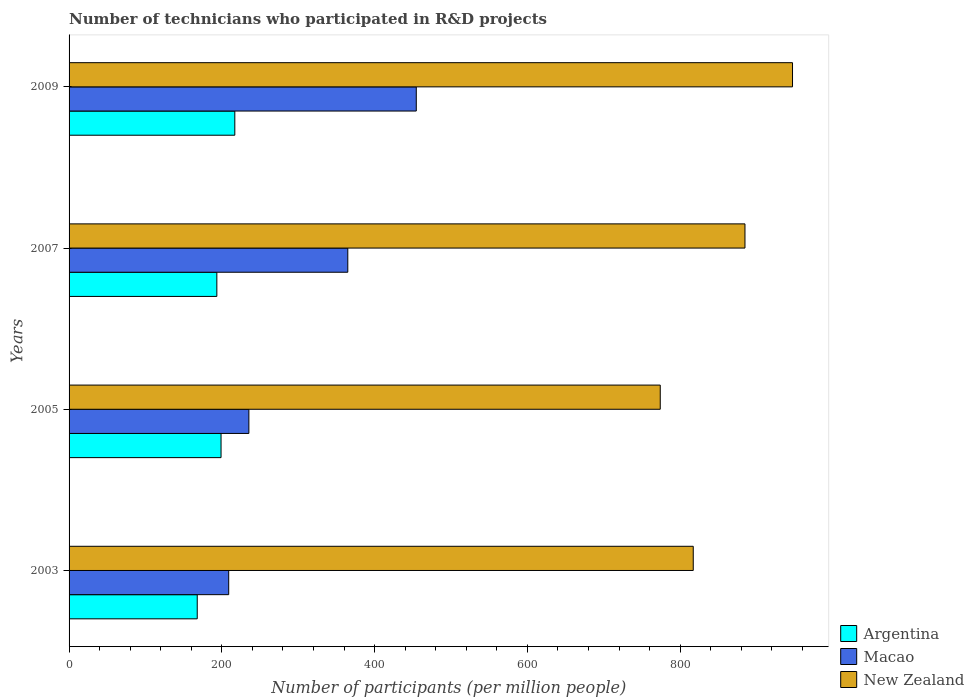How many groups of bars are there?
Offer a very short reply. 4. Are the number of bars on each tick of the Y-axis equal?
Provide a short and direct response. Yes. How many bars are there on the 1st tick from the top?
Provide a short and direct response. 3. What is the label of the 1st group of bars from the top?
Ensure brevity in your answer.  2009. What is the number of technicians who participated in R&D projects in New Zealand in 2005?
Your answer should be very brief. 773.94. Across all years, what is the maximum number of technicians who participated in R&D projects in Argentina?
Provide a short and direct response. 216.97. Across all years, what is the minimum number of technicians who participated in R&D projects in Macao?
Your response must be concise. 208.98. What is the total number of technicians who participated in R&D projects in New Zealand in the graph?
Make the answer very short. 3422.98. What is the difference between the number of technicians who participated in R&D projects in Argentina in 2003 and that in 2007?
Provide a succinct answer. -25.65. What is the difference between the number of technicians who participated in R&D projects in New Zealand in 2009 and the number of technicians who participated in R&D projects in Macao in 2003?
Give a very brief answer. 738.09. What is the average number of technicians who participated in R&D projects in Macao per year?
Your answer should be compact. 315.95. In the year 2005, what is the difference between the number of technicians who participated in R&D projects in New Zealand and number of technicians who participated in R&D projects in Macao?
Keep it short and to the point. 538.54. What is the ratio of the number of technicians who participated in R&D projects in Argentina in 2003 to that in 2005?
Make the answer very short. 0.84. Is the number of technicians who participated in R&D projects in New Zealand in 2003 less than that in 2007?
Offer a terse response. Yes. Is the difference between the number of technicians who participated in R&D projects in New Zealand in 2003 and 2005 greater than the difference between the number of technicians who participated in R&D projects in Macao in 2003 and 2005?
Your response must be concise. Yes. What is the difference between the highest and the second highest number of technicians who participated in R&D projects in Macao?
Your answer should be very brief. 89.65. What is the difference between the highest and the lowest number of technicians who participated in R&D projects in Argentina?
Your answer should be compact. 49.18. In how many years, is the number of technicians who participated in R&D projects in Argentina greater than the average number of technicians who participated in R&D projects in Argentina taken over all years?
Ensure brevity in your answer.  2. Is the sum of the number of technicians who participated in R&D projects in Macao in 2003 and 2005 greater than the maximum number of technicians who participated in R&D projects in Argentina across all years?
Ensure brevity in your answer.  Yes. What does the 2nd bar from the bottom in 2009 represents?
Provide a succinct answer. Macao. How many bars are there?
Provide a short and direct response. 12. How many years are there in the graph?
Ensure brevity in your answer.  4. What is the difference between two consecutive major ticks on the X-axis?
Keep it short and to the point. 200. Where does the legend appear in the graph?
Provide a short and direct response. Bottom right. How are the legend labels stacked?
Your response must be concise. Vertical. What is the title of the graph?
Provide a short and direct response. Number of technicians who participated in R&D projects. Does "Mauritania" appear as one of the legend labels in the graph?
Offer a terse response. No. What is the label or title of the X-axis?
Provide a short and direct response. Number of participants (per million people). What is the label or title of the Y-axis?
Your response must be concise. Years. What is the Number of participants (per million people) in Argentina in 2003?
Your answer should be very brief. 167.79. What is the Number of participants (per million people) in Macao in 2003?
Your answer should be very brief. 208.98. What is the Number of participants (per million people) of New Zealand in 2003?
Provide a succinct answer. 817.12. What is the Number of participants (per million people) of Argentina in 2005?
Give a very brief answer. 198.95. What is the Number of participants (per million people) in Macao in 2005?
Provide a short and direct response. 235.4. What is the Number of participants (per million people) in New Zealand in 2005?
Your response must be concise. 773.94. What is the Number of participants (per million people) in Argentina in 2007?
Give a very brief answer. 193.45. What is the Number of participants (per million people) of Macao in 2007?
Your answer should be very brief. 364.89. What is the Number of participants (per million people) in New Zealand in 2007?
Your answer should be very brief. 884.85. What is the Number of participants (per million people) of Argentina in 2009?
Your response must be concise. 216.97. What is the Number of participants (per million people) in Macao in 2009?
Ensure brevity in your answer.  454.54. What is the Number of participants (per million people) of New Zealand in 2009?
Give a very brief answer. 947.07. Across all years, what is the maximum Number of participants (per million people) of Argentina?
Offer a very short reply. 216.97. Across all years, what is the maximum Number of participants (per million people) of Macao?
Your response must be concise. 454.54. Across all years, what is the maximum Number of participants (per million people) in New Zealand?
Keep it short and to the point. 947.07. Across all years, what is the minimum Number of participants (per million people) of Argentina?
Provide a short and direct response. 167.79. Across all years, what is the minimum Number of participants (per million people) of Macao?
Your answer should be compact. 208.98. Across all years, what is the minimum Number of participants (per million people) in New Zealand?
Your answer should be very brief. 773.94. What is the total Number of participants (per million people) of Argentina in the graph?
Offer a terse response. 777.16. What is the total Number of participants (per million people) in Macao in the graph?
Give a very brief answer. 1263.81. What is the total Number of participants (per million people) of New Zealand in the graph?
Provide a short and direct response. 3422.98. What is the difference between the Number of participants (per million people) of Argentina in 2003 and that in 2005?
Ensure brevity in your answer.  -31.16. What is the difference between the Number of participants (per million people) of Macao in 2003 and that in 2005?
Your answer should be compact. -26.41. What is the difference between the Number of participants (per million people) in New Zealand in 2003 and that in 2005?
Your answer should be compact. 43.19. What is the difference between the Number of participants (per million people) in Argentina in 2003 and that in 2007?
Provide a short and direct response. -25.65. What is the difference between the Number of participants (per million people) of Macao in 2003 and that in 2007?
Ensure brevity in your answer.  -155.91. What is the difference between the Number of participants (per million people) in New Zealand in 2003 and that in 2007?
Provide a succinct answer. -67.72. What is the difference between the Number of participants (per million people) in Argentina in 2003 and that in 2009?
Keep it short and to the point. -49.18. What is the difference between the Number of participants (per million people) of Macao in 2003 and that in 2009?
Provide a short and direct response. -245.56. What is the difference between the Number of participants (per million people) of New Zealand in 2003 and that in 2009?
Give a very brief answer. -129.95. What is the difference between the Number of participants (per million people) of Argentina in 2005 and that in 2007?
Offer a terse response. 5.5. What is the difference between the Number of participants (per million people) of Macao in 2005 and that in 2007?
Your response must be concise. -129.5. What is the difference between the Number of participants (per million people) in New Zealand in 2005 and that in 2007?
Your answer should be very brief. -110.91. What is the difference between the Number of participants (per million people) in Argentina in 2005 and that in 2009?
Your answer should be very brief. -18.02. What is the difference between the Number of participants (per million people) in Macao in 2005 and that in 2009?
Ensure brevity in your answer.  -219.15. What is the difference between the Number of participants (per million people) in New Zealand in 2005 and that in 2009?
Offer a very short reply. -173.14. What is the difference between the Number of participants (per million people) of Argentina in 2007 and that in 2009?
Keep it short and to the point. -23.52. What is the difference between the Number of participants (per million people) of Macao in 2007 and that in 2009?
Your response must be concise. -89.65. What is the difference between the Number of participants (per million people) in New Zealand in 2007 and that in 2009?
Ensure brevity in your answer.  -62.23. What is the difference between the Number of participants (per million people) in Argentina in 2003 and the Number of participants (per million people) in Macao in 2005?
Your answer should be very brief. -67.6. What is the difference between the Number of participants (per million people) in Argentina in 2003 and the Number of participants (per million people) in New Zealand in 2005?
Provide a short and direct response. -606.15. What is the difference between the Number of participants (per million people) in Macao in 2003 and the Number of participants (per million people) in New Zealand in 2005?
Your response must be concise. -564.95. What is the difference between the Number of participants (per million people) of Argentina in 2003 and the Number of participants (per million people) of Macao in 2007?
Make the answer very short. -197.1. What is the difference between the Number of participants (per million people) in Argentina in 2003 and the Number of participants (per million people) in New Zealand in 2007?
Make the answer very short. -717.06. What is the difference between the Number of participants (per million people) in Macao in 2003 and the Number of participants (per million people) in New Zealand in 2007?
Offer a very short reply. -675.86. What is the difference between the Number of participants (per million people) of Argentina in 2003 and the Number of participants (per million people) of Macao in 2009?
Your answer should be compact. -286.75. What is the difference between the Number of participants (per million people) in Argentina in 2003 and the Number of participants (per million people) in New Zealand in 2009?
Ensure brevity in your answer.  -779.28. What is the difference between the Number of participants (per million people) in Macao in 2003 and the Number of participants (per million people) in New Zealand in 2009?
Provide a short and direct response. -738.09. What is the difference between the Number of participants (per million people) in Argentina in 2005 and the Number of participants (per million people) in Macao in 2007?
Give a very brief answer. -165.94. What is the difference between the Number of participants (per million people) of Argentina in 2005 and the Number of participants (per million people) of New Zealand in 2007?
Offer a very short reply. -685.9. What is the difference between the Number of participants (per million people) in Macao in 2005 and the Number of participants (per million people) in New Zealand in 2007?
Your response must be concise. -649.45. What is the difference between the Number of participants (per million people) in Argentina in 2005 and the Number of participants (per million people) in Macao in 2009?
Provide a short and direct response. -255.59. What is the difference between the Number of participants (per million people) of Argentina in 2005 and the Number of participants (per million people) of New Zealand in 2009?
Provide a succinct answer. -748.12. What is the difference between the Number of participants (per million people) of Macao in 2005 and the Number of participants (per million people) of New Zealand in 2009?
Make the answer very short. -711.68. What is the difference between the Number of participants (per million people) of Argentina in 2007 and the Number of participants (per million people) of Macao in 2009?
Your answer should be very brief. -261.1. What is the difference between the Number of participants (per million people) in Argentina in 2007 and the Number of participants (per million people) in New Zealand in 2009?
Give a very brief answer. -753.63. What is the difference between the Number of participants (per million people) of Macao in 2007 and the Number of participants (per million people) of New Zealand in 2009?
Ensure brevity in your answer.  -582.18. What is the average Number of participants (per million people) in Argentina per year?
Your response must be concise. 194.29. What is the average Number of participants (per million people) in Macao per year?
Your response must be concise. 315.95. What is the average Number of participants (per million people) in New Zealand per year?
Offer a very short reply. 855.75. In the year 2003, what is the difference between the Number of participants (per million people) in Argentina and Number of participants (per million people) in Macao?
Your answer should be very brief. -41.19. In the year 2003, what is the difference between the Number of participants (per million people) in Argentina and Number of participants (per million people) in New Zealand?
Offer a terse response. -649.33. In the year 2003, what is the difference between the Number of participants (per million people) in Macao and Number of participants (per million people) in New Zealand?
Your answer should be compact. -608.14. In the year 2005, what is the difference between the Number of participants (per million people) in Argentina and Number of participants (per million people) in Macao?
Give a very brief answer. -36.45. In the year 2005, what is the difference between the Number of participants (per million people) in Argentina and Number of participants (per million people) in New Zealand?
Offer a terse response. -574.99. In the year 2005, what is the difference between the Number of participants (per million people) of Macao and Number of participants (per million people) of New Zealand?
Keep it short and to the point. -538.54. In the year 2007, what is the difference between the Number of participants (per million people) in Argentina and Number of participants (per million people) in Macao?
Give a very brief answer. -171.45. In the year 2007, what is the difference between the Number of participants (per million people) of Argentina and Number of participants (per million people) of New Zealand?
Give a very brief answer. -691.4. In the year 2007, what is the difference between the Number of participants (per million people) of Macao and Number of participants (per million people) of New Zealand?
Your answer should be very brief. -519.95. In the year 2009, what is the difference between the Number of participants (per million people) in Argentina and Number of participants (per million people) in Macao?
Offer a very short reply. -237.57. In the year 2009, what is the difference between the Number of participants (per million people) in Argentina and Number of participants (per million people) in New Zealand?
Offer a terse response. -730.11. In the year 2009, what is the difference between the Number of participants (per million people) in Macao and Number of participants (per million people) in New Zealand?
Offer a terse response. -492.53. What is the ratio of the Number of participants (per million people) in Argentina in 2003 to that in 2005?
Give a very brief answer. 0.84. What is the ratio of the Number of participants (per million people) of Macao in 2003 to that in 2005?
Keep it short and to the point. 0.89. What is the ratio of the Number of participants (per million people) in New Zealand in 2003 to that in 2005?
Give a very brief answer. 1.06. What is the ratio of the Number of participants (per million people) of Argentina in 2003 to that in 2007?
Your response must be concise. 0.87. What is the ratio of the Number of participants (per million people) in Macao in 2003 to that in 2007?
Your response must be concise. 0.57. What is the ratio of the Number of participants (per million people) of New Zealand in 2003 to that in 2007?
Provide a short and direct response. 0.92. What is the ratio of the Number of participants (per million people) of Argentina in 2003 to that in 2009?
Offer a very short reply. 0.77. What is the ratio of the Number of participants (per million people) in Macao in 2003 to that in 2009?
Keep it short and to the point. 0.46. What is the ratio of the Number of participants (per million people) in New Zealand in 2003 to that in 2009?
Offer a very short reply. 0.86. What is the ratio of the Number of participants (per million people) of Argentina in 2005 to that in 2007?
Give a very brief answer. 1.03. What is the ratio of the Number of participants (per million people) of Macao in 2005 to that in 2007?
Your answer should be compact. 0.65. What is the ratio of the Number of participants (per million people) of New Zealand in 2005 to that in 2007?
Offer a terse response. 0.87. What is the ratio of the Number of participants (per million people) in Argentina in 2005 to that in 2009?
Keep it short and to the point. 0.92. What is the ratio of the Number of participants (per million people) of Macao in 2005 to that in 2009?
Make the answer very short. 0.52. What is the ratio of the Number of participants (per million people) of New Zealand in 2005 to that in 2009?
Offer a very short reply. 0.82. What is the ratio of the Number of participants (per million people) of Argentina in 2007 to that in 2009?
Offer a terse response. 0.89. What is the ratio of the Number of participants (per million people) in Macao in 2007 to that in 2009?
Provide a short and direct response. 0.8. What is the ratio of the Number of participants (per million people) in New Zealand in 2007 to that in 2009?
Give a very brief answer. 0.93. What is the difference between the highest and the second highest Number of participants (per million people) in Argentina?
Offer a very short reply. 18.02. What is the difference between the highest and the second highest Number of participants (per million people) in Macao?
Offer a very short reply. 89.65. What is the difference between the highest and the second highest Number of participants (per million people) of New Zealand?
Ensure brevity in your answer.  62.23. What is the difference between the highest and the lowest Number of participants (per million people) of Argentina?
Make the answer very short. 49.18. What is the difference between the highest and the lowest Number of participants (per million people) of Macao?
Provide a succinct answer. 245.56. What is the difference between the highest and the lowest Number of participants (per million people) of New Zealand?
Give a very brief answer. 173.14. 